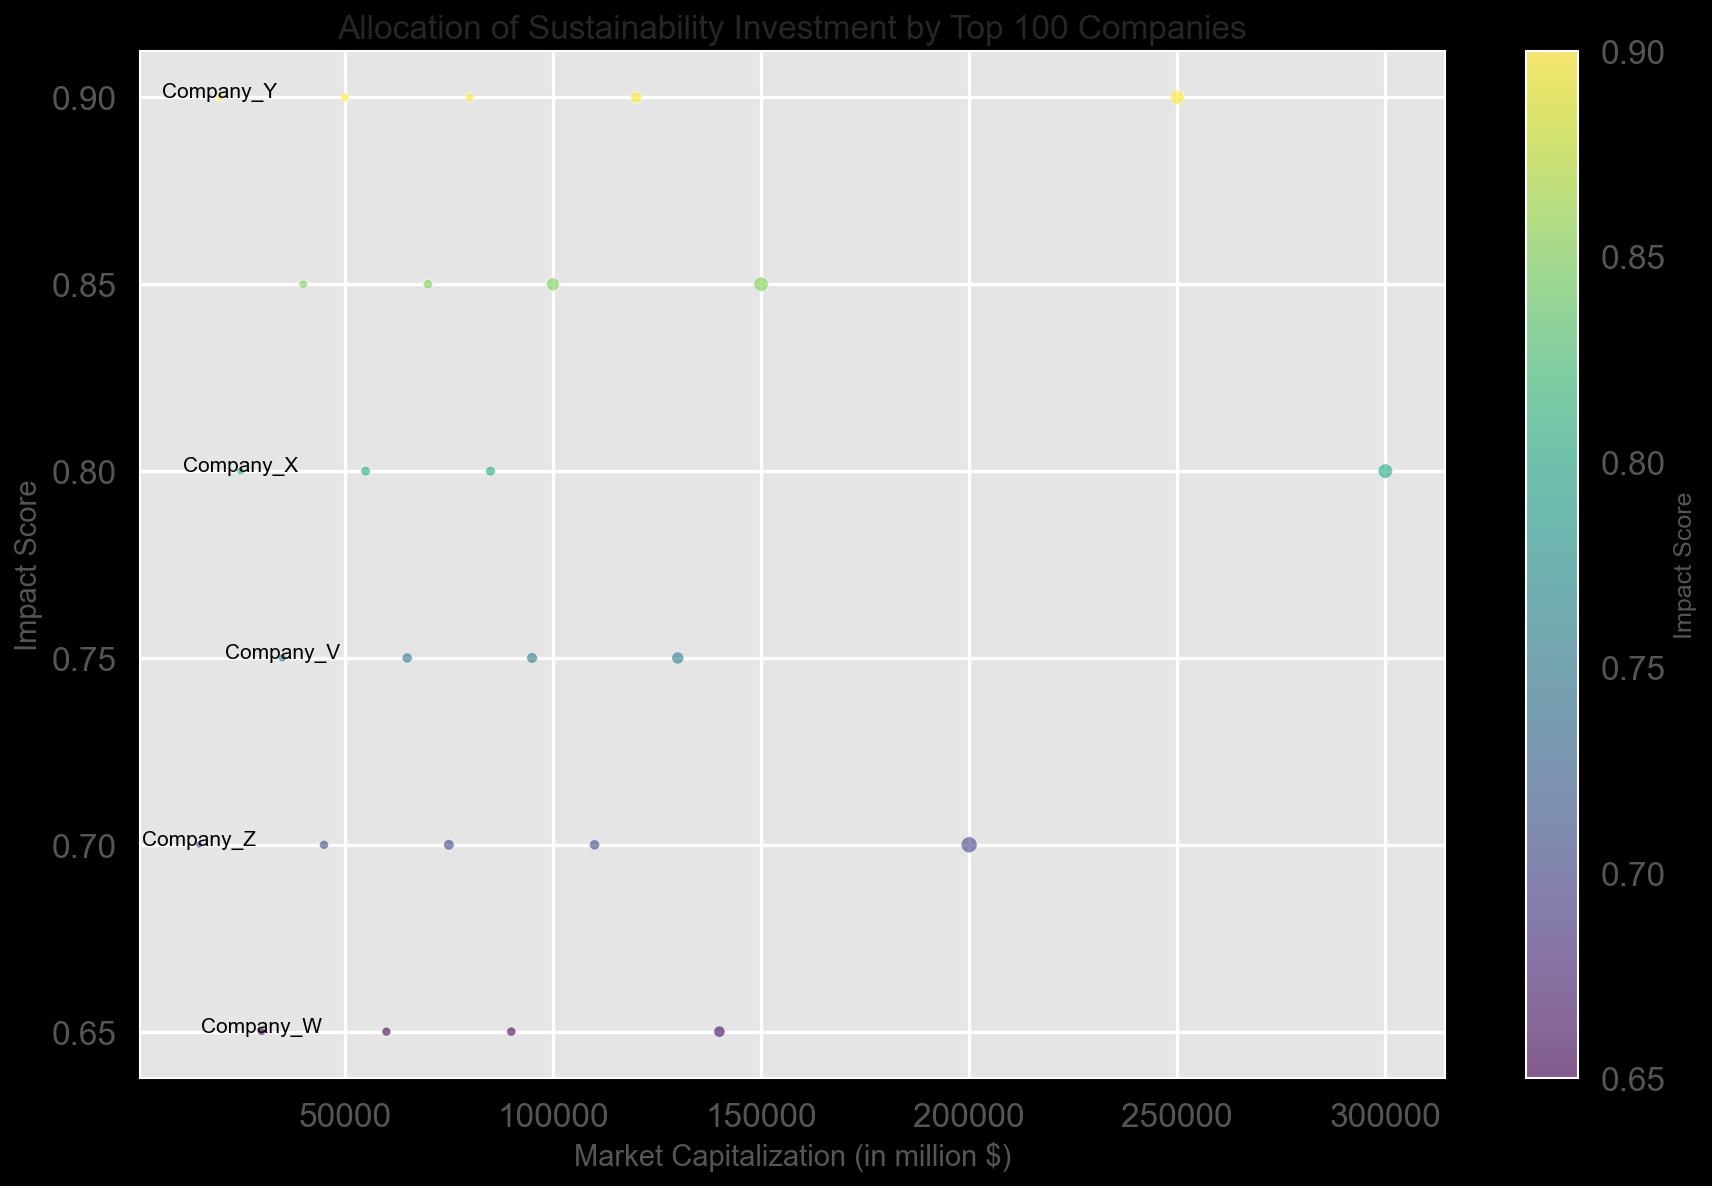What is the company with the largest Market Capitalization? To find the company with the largest market capitalization, look for the company with the highest value on the x-axis. Company A is positioned the farthest right on the x-axis, indicating it has the largest market capitalization.
Answer: Company A Which company has the highest Impact Score? The company with the highest Impact Score is the one positioned at the top of the figure. Company B is at the highest point on the y-axis, indicating it has the highest Impact Score.
Answer: Company B Which company has the smallest Investment in Sustainability, and what is it? The size of the bubbles represents the Investment in Sustainability. The smallest bubble visually indicates the company with the smallest investment. Company Z has the smallest bubble and given the data, its Investment in Sustainability is $10,000.
Answer: Company Z, $10,000 How many companies have an Impact Score greater than 0.8 and a Market Capitalization greater than 100,000? To determine this, find bubbles located above 0.8 on the y-axis and to the right of 100,000 on the x-axis. Companies A, B, D, and I fulfill both criteria, making a total of 4 companies.
Answer: 4 companies Which company with a Market Capitalization less than 50,000 has the highest Impact Score? First, consider companies that have an x-axis value of less than 50,000. Then, identify the one with the highest y-axis value. Company S is the highest bubble among those with Market Capitalization less than 50,000.
Answer: Company S Compare Company G and Company L in terms of Market Capitalization and Impact Score. Company G and Company L are visually compared by their x and y-axis positions. Company G has a Market Capitalization of 120,000 and an Impact Score of 0.9. Company L has a Market Capitalization of 85,000 and an Impact Score of 0.8, indicating Company G has a higher Market Capitalization and Impact Score than Company L.
Answer: Company G has a higher Market Capitalization and Impact Score What is the average Investment in Sustainability for companies with an Impact Score of 0.9? Identify all companies with Impact Score equal to 0.9: Companies B, G, M, S, and Y. Summing their Investments in Sustainability: 45,000 + 30,000 + 18,000 + 16,000 + 12,000 = 121,000. Dividing by 5 gives an average of 24,200.
Answer: $24,200 Identify the top three companies by Market Capitalization and provide their respective Impact Scores. Find the three companies positioned the farthest to the right on the x-axis. They are Companies A, B, and C. Their Impact Scores can be read from the y-axis: Company A (0.8), Company B (0.9), Company C (0.7).
Answer: Company A (0.8), Company B (0.9), Company C (0.7) How does the color of the bubbles relate to the Impact Score? The color gradient changes with the Impact Score, with lower scores being on the lighter end of the spectrum and higher scores on the darker end. Darker bubbles represent higher Impact Scores, and lighter bubbles represent lower Impact Scores.
Answer: Darker means higher Impact Score 